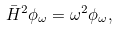Convert formula to latex. <formula><loc_0><loc_0><loc_500><loc_500>\bar { H } ^ { 2 } \phi _ { \omega } = \omega ^ { 2 } \phi _ { \omega } ,</formula> 